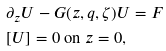<formula> <loc_0><loc_0><loc_500><loc_500>& \partial _ { z } U - G ( z , q , \zeta ) U = F \\ & [ U ] = 0 \text { on } z = 0 ,</formula> 